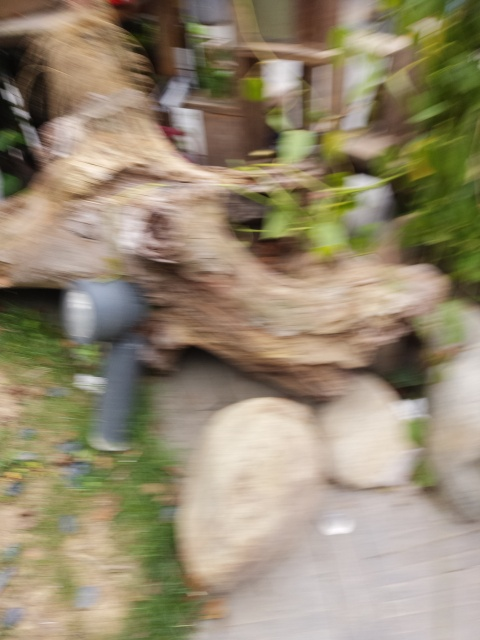Is the image well-detailed? The image's details are not clear due to motion blur, which obscures the finer elements and makes the image appear less detailed. The scene seems to include a wood log and some foliage in a natural setting, but the lack of sharpness prevents a comprehensive analysis of the details. 